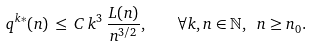<formula> <loc_0><loc_0><loc_500><loc_500>q ^ { k * } ( n ) \, \leq \, C \, k ^ { 3 } \, \frac { L ( n ) } { n ^ { 3 / 2 } } , \quad \forall k , n \in { \mathbb { N } } , \ n \geq n _ { 0 } .</formula> 